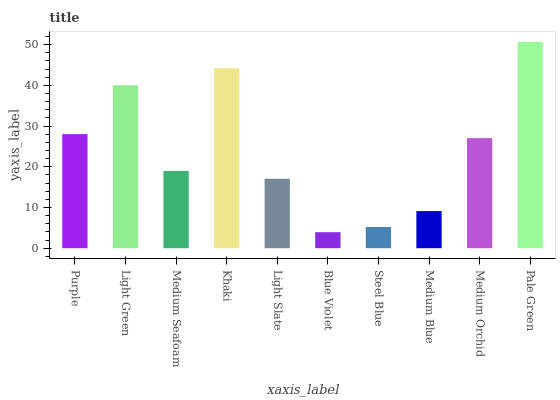Is Blue Violet the minimum?
Answer yes or no. Yes. Is Pale Green the maximum?
Answer yes or no. Yes. Is Light Green the minimum?
Answer yes or no. No. Is Light Green the maximum?
Answer yes or no. No. Is Light Green greater than Purple?
Answer yes or no. Yes. Is Purple less than Light Green?
Answer yes or no. Yes. Is Purple greater than Light Green?
Answer yes or no. No. Is Light Green less than Purple?
Answer yes or no. No. Is Medium Orchid the high median?
Answer yes or no. Yes. Is Medium Seafoam the low median?
Answer yes or no. Yes. Is Blue Violet the high median?
Answer yes or no. No. Is Purple the low median?
Answer yes or no. No. 